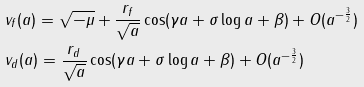Convert formula to latex. <formula><loc_0><loc_0><loc_500><loc_500>& v _ { f } ( a ) = \sqrt { - \mu } + \frac { r _ { f } } { \sqrt { a } } \cos ( \gamma a + \sigma \log a + \beta ) + O ( a ^ { - \frac { 3 } { 2 } } ) \\ & v _ { d } ( a ) = \frac { r _ { d } } { \sqrt { a } } \cos ( \gamma a + \sigma \log a + \beta ) + O ( a ^ { - \frac { 3 } { 2 } } )</formula> 